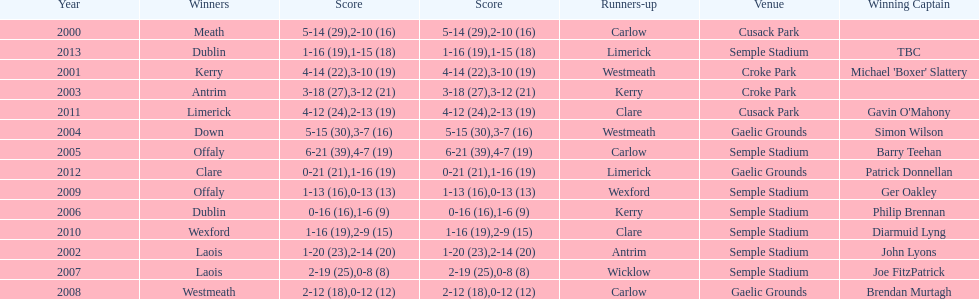How many times was carlow the runner-up? 3. 